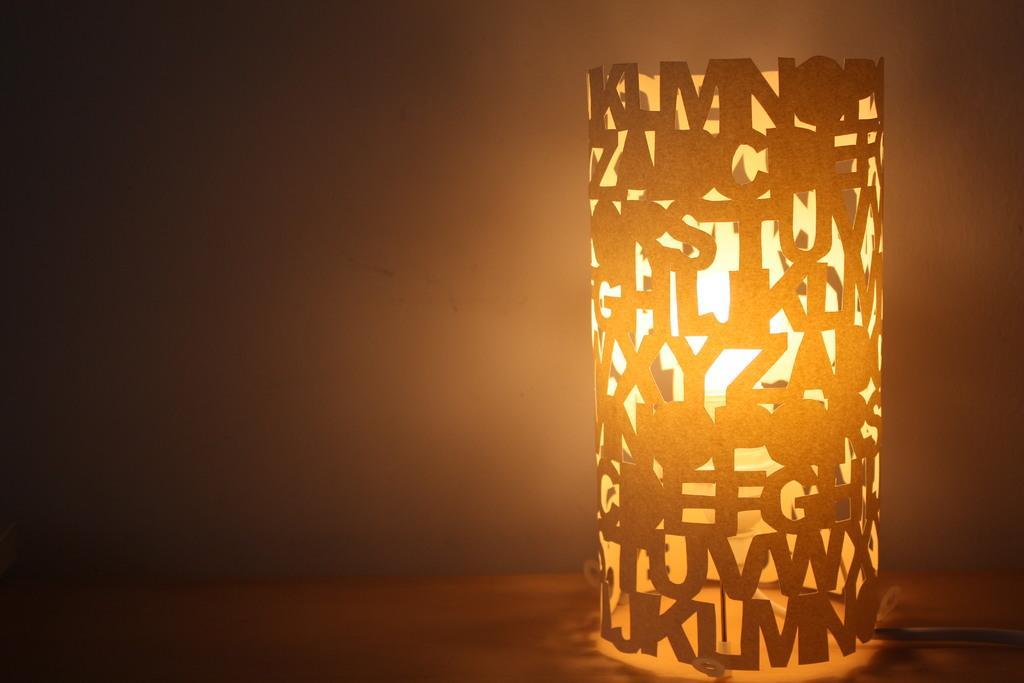In one or two sentences, can you explain what this image depicts? In the picture we can see a light and around it we can see a covered art with alphabets shaped cutting to it. 